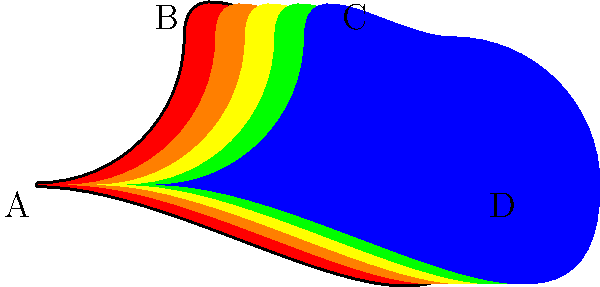Based on the heat map of a roller skating race track shown above, which path would be the most efficient for a speed skater to follow, and why? To determine the most efficient path for a speed skater, we need to analyze the heat map and understand its implications:

1. The heat map uses colors to represent the efficiency of different paths, with red being the least efficient and blue being the most efficient.

2. We can observe that the outer edge of the track (closest to the blue area) is consistently the most efficient path throughout the entire circuit.

3. This is because:
   a) The outer path minimizes the total distance traveled, as it follows the straightest possible line around the track.
   b) It allows the skater to maintain a higher speed by reducing the need for sharp turns or sudden changes in direction.

4. The purple arrow in the diagram illustrates this optimal path, which stays close to the outer edge of the track throughout the entire lap.

5. Specifically, the most efficient path would be:
   - Starting from point A, staying close to the outer edge while approaching the first turn.
   - Maintaining the outer line through points B and C, utilizing the full width of the track on the straightaway.
   - Continuing on the outer edge while approaching and exiting the final turn near point D.
   - Finishing the lap by staying on the outside edge back to point A.

6. By following this path, a speed skater can:
   - Minimize the total distance traveled
   - Maintain higher speeds throughout the lap
   - Reduce energy expenditure on unnecessary turns or direction changes

This strategy aligns with the persona of an eager roller skater specializing in speed events, as it focuses on maximizing efficiency and speed for competitive performance.
Answer: The outer edge of the track (blue area) 